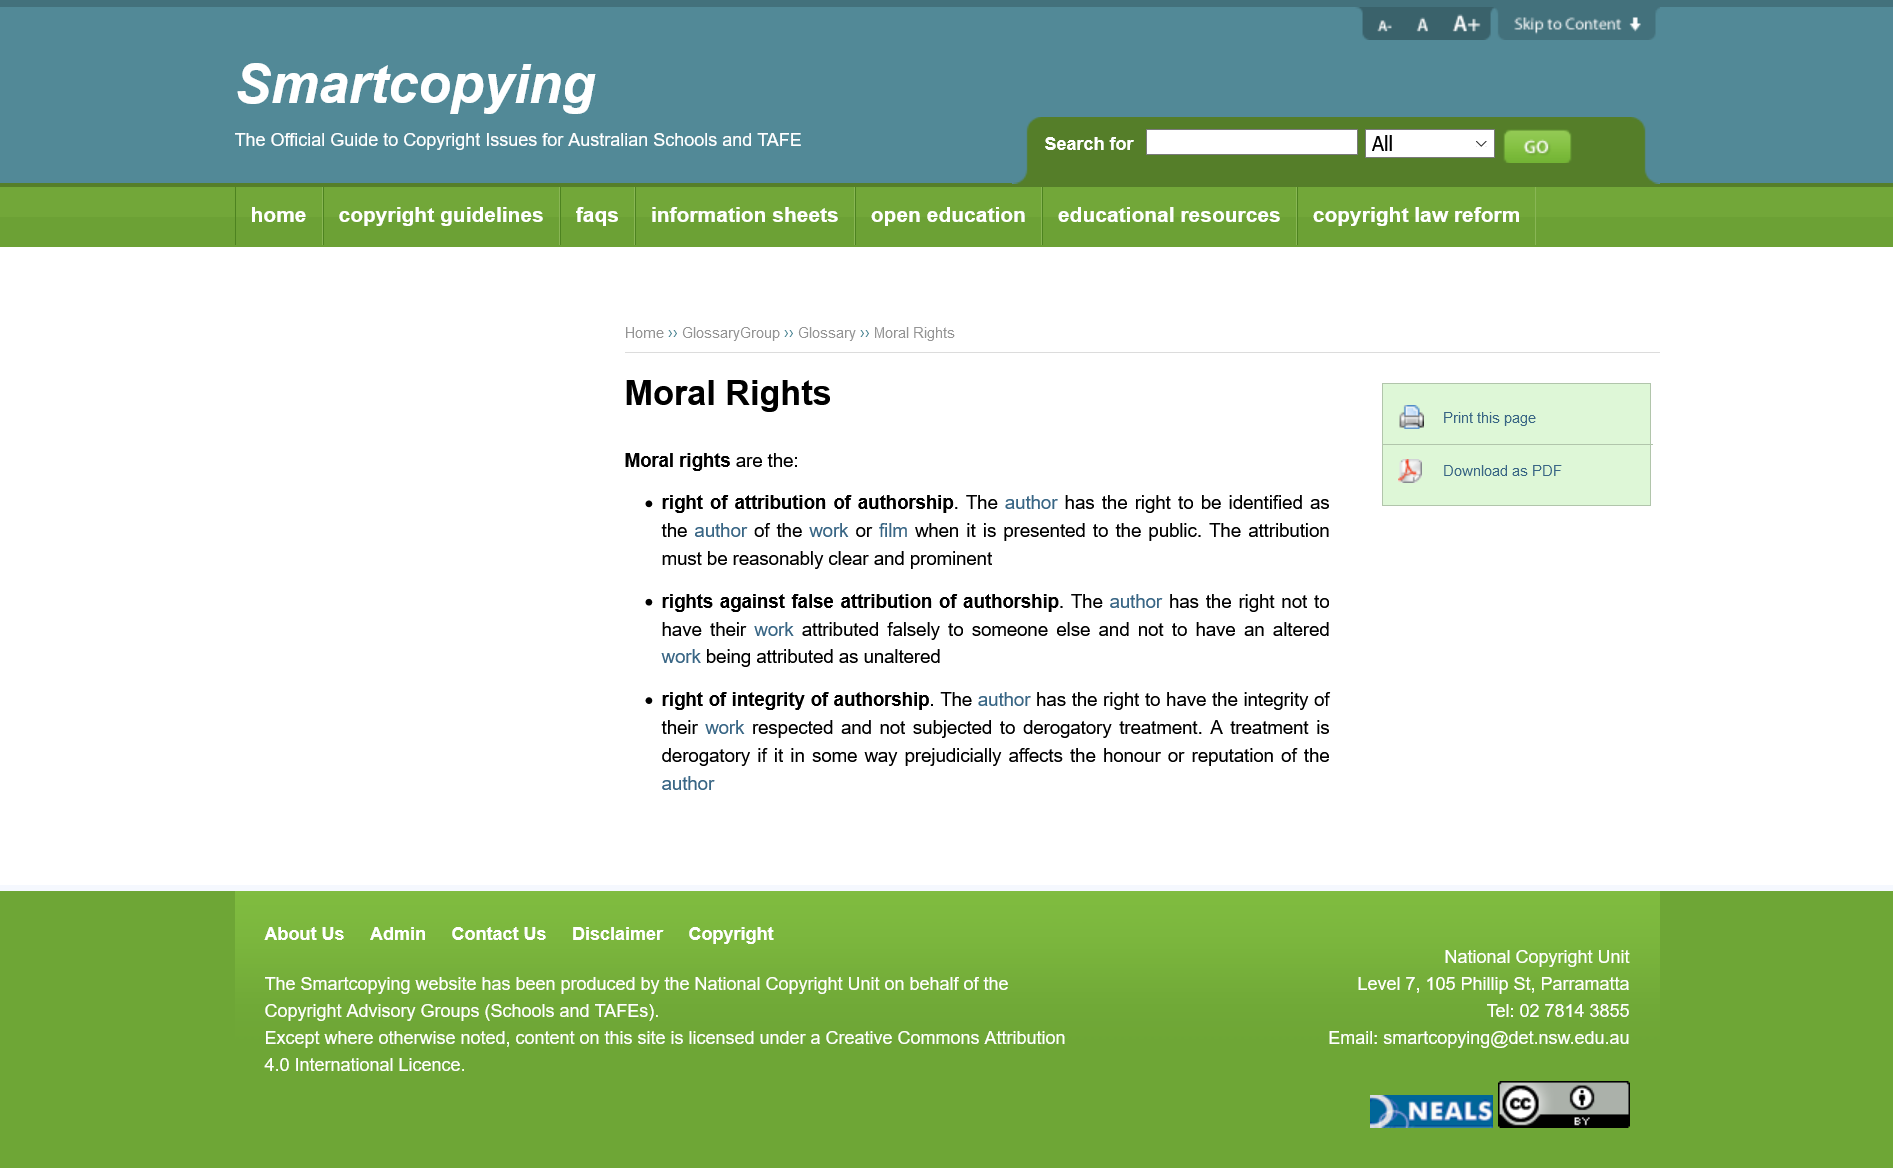Point out several critical features in this image. The right of attribution of authorship and the rights against false attribution of authorship concern moral rights and are essential to the protection of authorship in a work. When an author's work or film is presented to the public, the author is guaranteed the right of attribution of authorship, as well as other moral rights, including the right of integrity and the right to prevent distortion, mutilation or other act in relation to the work that would be prejudicial to his honor or reputation. An author's honor and reputation can be prejudicially affected if subjected to derogatory treatment. 